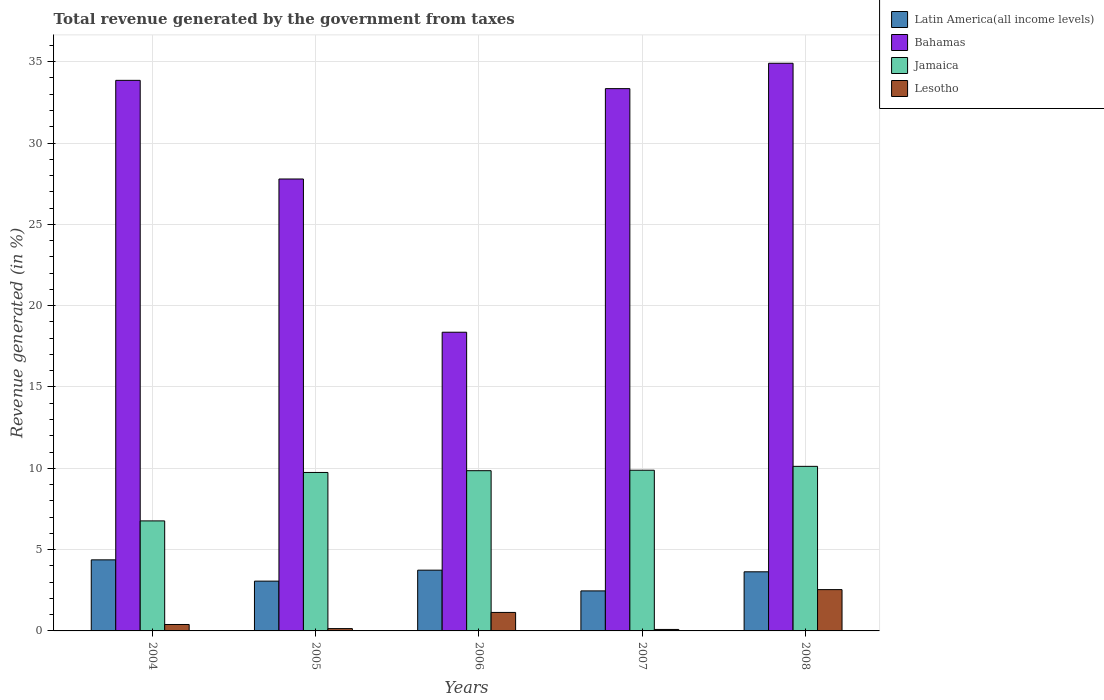How many groups of bars are there?
Give a very brief answer. 5. How many bars are there on the 2nd tick from the left?
Provide a short and direct response. 4. What is the label of the 1st group of bars from the left?
Provide a succinct answer. 2004. In how many cases, is the number of bars for a given year not equal to the number of legend labels?
Offer a terse response. 0. What is the total revenue generated in Latin America(all income levels) in 2006?
Ensure brevity in your answer.  3.74. Across all years, what is the maximum total revenue generated in Lesotho?
Your answer should be compact. 2.54. Across all years, what is the minimum total revenue generated in Bahamas?
Provide a short and direct response. 18.37. In which year was the total revenue generated in Bahamas maximum?
Provide a short and direct response. 2008. In which year was the total revenue generated in Bahamas minimum?
Your answer should be compact. 2006. What is the total total revenue generated in Jamaica in the graph?
Provide a short and direct response. 46.36. What is the difference between the total revenue generated in Bahamas in 2005 and that in 2008?
Keep it short and to the point. -7.12. What is the difference between the total revenue generated in Jamaica in 2007 and the total revenue generated in Bahamas in 2005?
Offer a very short reply. -17.91. What is the average total revenue generated in Lesotho per year?
Offer a terse response. 0.86. In the year 2007, what is the difference between the total revenue generated in Jamaica and total revenue generated in Bahamas?
Your answer should be compact. -23.46. What is the ratio of the total revenue generated in Lesotho in 2004 to that in 2005?
Your answer should be compact. 2.77. Is the total revenue generated in Lesotho in 2004 less than that in 2007?
Offer a very short reply. No. What is the difference between the highest and the second highest total revenue generated in Lesotho?
Provide a short and direct response. 1.4. What is the difference between the highest and the lowest total revenue generated in Lesotho?
Make the answer very short. 2.45. In how many years, is the total revenue generated in Jamaica greater than the average total revenue generated in Jamaica taken over all years?
Provide a succinct answer. 4. Is it the case that in every year, the sum of the total revenue generated in Lesotho and total revenue generated in Bahamas is greater than the sum of total revenue generated in Jamaica and total revenue generated in Latin America(all income levels)?
Offer a terse response. No. What does the 3rd bar from the left in 2006 represents?
Your response must be concise. Jamaica. What does the 2nd bar from the right in 2007 represents?
Provide a short and direct response. Jamaica. Is it the case that in every year, the sum of the total revenue generated in Bahamas and total revenue generated in Lesotho is greater than the total revenue generated in Jamaica?
Your answer should be compact. Yes. Are all the bars in the graph horizontal?
Make the answer very short. No. Does the graph contain grids?
Ensure brevity in your answer.  Yes. How many legend labels are there?
Make the answer very short. 4. What is the title of the graph?
Keep it short and to the point. Total revenue generated by the government from taxes. Does "Cameroon" appear as one of the legend labels in the graph?
Ensure brevity in your answer.  No. What is the label or title of the X-axis?
Offer a very short reply. Years. What is the label or title of the Y-axis?
Your answer should be very brief. Revenue generated (in %). What is the Revenue generated (in %) of Latin America(all income levels) in 2004?
Keep it short and to the point. 4.37. What is the Revenue generated (in %) in Bahamas in 2004?
Provide a succinct answer. 33.85. What is the Revenue generated (in %) in Jamaica in 2004?
Your response must be concise. 6.77. What is the Revenue generated (in %) in Lesotho in 2004?
Ensure brevity in your answer.  0.4. What is the Revenue generated (in %) in Latin America(all income levels) in 2005?
Keep it short and to the point. 3.06. What is the Revenue generated (in %) in Bahamas in 2005?
Your answer should be compact. 27.79. What is the Revenue generated (in %) in Jamaica in 2005?
Keep it short and to the point. 9.74. What is the Revenue generated (in %) of Lesotho in 2005?
Provide a short and direct response. 0.14. What is the Revenue generated (in %) in Latin America(all income levels) in 2006?
Keep it short and to the point. 3.74. What is the Revenue generated (in %) of Bahamas in 2006?
Your answer should be compact. 18.37. What is the Revenue generated (in %) of Jamaica in 2006?
Provide a succinct answer. 9.85. What is the Revenue generated (in %) in Lesotho in 2006?
Offer a terse response. 1.14. What is the Revenue generated (in %) in Latin America(all income levels) in 2007?
Your answer should be very brief. 2.46. What is the Revenue generated (in %) of Bahamas in 2007?
Offer a very short reply. 33.35. What is the Revenue generated (in %) of Jamaica in 2007?
Offer a very short reply. 9.88. What is the Revenue generated (in %) of Lesotho in 2007?
Provide a succinct answer. 0.09. What is the Revenue generated (in %) of Latin America(all income levels) in 2008?
Provide a short and direct response. 3.64. What is the Revenue generated (in %) of Bahamas in 2008?
Provide a short and direct response. 34.91. What is the Revenue generated (in %) of Jamaica in 2008?
Offer a terse response. 10.12. What is the Revenue generated (in %) in Lesotho in 2008?
Ensure brevity in your answer.  2.54. Across all years, what is the maximum Revenue generated (in %) of Latin America(all income levels)?
Provide a succinct answer. 4.37. Across all years, what is the maximum Revenue generated (in %) of Bahamas?
Ensure brevity in your answer.  34.91. Across all years, what is the maximum Revenue generated (in %) in Jamaica?
Your response must be concise. 10.12. Across all years, what is the maximum Revenue generated (in %) in Lesotho?
Provide a short and direct response. 2.54. Across all years, what is the minimum Revenue generated (in %) in Latin America(all income levels)?
Keep it short and to the point. 2.46. Across all years, what is the minimum Revenue generated (in %) of Bahamas?
Your response must be concise. 18.37. Across all years, what is the minimum Revenue generated (in %) in Jamaica?
Offer a very short reply. 6.77. Across all years, what is the minimum Revenue generated (in %) in Lesotho?
Provide a short and direct response. 0.09. What is the total Revenue generated (in %) of Latin America(all income levels) in the graph?
Provide a succinct answer. 17.26. What is the total Revenue generated (in %) of Bahamas in the graph?
Give a very brief answer. 148.26. What is the total Revenue generated (in %) in Jamaica in the graph?
Your response must be concise. 46.36. What is the total Revenue generated (in %) in Lesotho in the graph?
Provide a short and direct response. 4.31. What is the difference between the Revenue generated (in %) of Latin America(all income levels) in 2004 and that in 2005?
Offer a terse response. 1.31. What is the difference between the Revenue generated (in %) in Bahamas in 2004 and that in 2005?
Your answer should be very brief. 6.07. What is the difference between the Revenue generated (in %) of Jamaica in 2004 and that in 2005?
Keep it short and to the point. -2.98. What is the difference between the Revenue generated (in %) in Lesotho in 2004 and that in 2005?
Provide a succinct answer. 0.25. What is the difference between the Revenue generated (in %) of Latin America(all income levels) in 2004 and that in 2006?
Give a very brief answer. 0.63. What is the difference between the Revenue generated (in %) of Bahamas in 2004 and that in 2006?
Provide a short and direct response. 15.49. What is the difference between the Revenue generated (in %) in Jamaica in 2004 and that in 2006?
Provide a short and direct response. -3.09. What is the difference between the Revenue generated (in %) of Lesotho in 2004 and that in 2006?
Your response must be concise. -0.74. What is the difference between the Revenue generated (in %) in Latin America(all income levels) in 2004 and that in 2007?
Make the answer very short. 1.91. What is the difference between the Revenue generated (in %) of Bahamas in 2004 and that in 2007?
Offer a very short reply. 0.51. What is the difference between the Revenue generated (in %) of Jamaica in 2004 and that in 2007?
Ensure brevity in your answer.  -3.12. What is the difference between the Revenue generated (in %) in Lesotho in 2004 and that in 2007?
Offer a terse response. 0.3. What is the difference between the Revenue generated (in %) in Latin America(all income levels) in 2004 and that in 2008?
Offer a very short reply. 0.73. What is the difference between the Revenue generated (in %) of Bahamas in 2004 and that in 2008?
Provide a succinct answer. -1.05. What is the difference between the Revenue generated (in %) of Jamaica in 2004 and that in 2008?
Offer a terse response. -3.35. What is the difference between the Revenue generated (in %) in Lesotho in 2004 and that in 2008?
Your answer should be compact. -2.14. What is the difference between the Revenue generated (in %) of Latin America(all income levels) in 2005 and that in 2006?
Provide a short and direct response. -0.67. What is the difference between the Revenue generated (in %) in Bahamas in 2005 and that in 2006?
Provide a short and direct response. 9.42. What is the difference between the Revenue generated (in %) of Jamaica in 2005 and that in 2006?
Your response must be concise. -0.11. What is the difference between the Revenue generated (in %) of Lesotho in 2005 and that in 2006?
Provide a short and direct response. -0.99. What is the difference between the Revenue generated (in %) of Latin America(all income levels) in 2005 and that in 2007?
Give a very brief answer. 0.6. What is the difference between the Revenue generated (in %) of Bahamas in 2005 and that in 2007?
Provide a succinct answer. -5.56. What is the difference between the Revenue generated (in %) of Jamaica in 2005 and that in 2007?
Offer a terse response. -0.14. What is the difference between the Revenue generated (in %) of Lesotho in 2005 and that in 2007?
Keep it short and to the point. 0.05. What is the difference between the Revenue generated (in %) in Latin America(all income levels) in 2005 and that in 2008?
Ensure brevity in your answer.  -0.57. What is the difference between the Revenue generated (in %) in Bahamas in 2005 and that in 2008?
Give a very brief answer. -7.12. What is the difference between the Revenue generated (in %) of Jamaica in 2005 and that in 2008?
Keep it short and to the point. -0.38. What is the difference between the Revenue generated (in %) of Lesotho in 2005 and that in 2008?
Give a very brief answer. -2.4. What is the difference between the Revenue generated (in %) of Latin America(all income levels) in 2006 and that in 2007?
Provide a short and direct response. 1.28. What is the difference between the Revenue generated (in %) of Bahamas in 2006 and that in 2007?
Provide a succinct answer. -14.98. What is the difference between the Revenue generated (in %) of Jamaica in 2006 and that in 2007?
Provide a succinct answer. -0.03. What is the difference between the Revenue generated (in %) in Lesotho in 2006 and that in 2007?
Keep it short and to the point. 1.05. What is the difference between the Revenue generated (in %) of Latin America(all income levels) in 2006 and that in 2008?
Your answer should be very brief. 0.1. What is the difference between the Revenue generated (in %) of Bahamas in 2006 and that in 2008?
Make the answer very short. -16.54. What is the difference between the Revenue generated (in %) in Jamaica in 2006 and that in 2008?
Offer a very short reply. -0.27. What is the difference between the Revenue generated (in %) of Lesotho in 2006 and that in 2008?
Provide a short and direct response. -1.4. What is the difference between the Revenue generated (in %) in Latin America(all income levels) in 2007 and that in 2008?
Your answer should be very brief. -1.17. What is the difference between the Revenue generated (in %) in Bahamas in 2007 and that in 2008?
Ensure brevity in your answer.  -1.56. What is the difference between the Revenue generated (in %) in Jamaica in 2007 and that in 2008?
Make the answer very short. -0.24. What is the difference between the Revenue generated (in %) of Lesotho in 2007 and that in 2008?
Your response must be concise. -2.45. What is the difference between the Revenue generated (in %) of Latin America(all income levels) in 2004 and the Revenue generated (in %) of Bahamas in 2005?
Offer a very short reply. -23.42. What is the difference between the Revenue generated (in %) in Latin America(all income levels) in 2004 and the Revenue generated (in %) in Jamaica in 2005?
Ensure brevity in your answer.  -5.37. What is the difference between the Revenue generated (in %) of Latin America(all income levels) in 2004 and the Revenue generated (in %) of Lesotho in 2005?
Provide a succinct answer. 4.23. What is the difference between the Revenue generated (in %) of Bahamas in 2004 and the Revenue generated (in %) of Jamaica in 2005?
Give a very brief answer. 24.11. What is the difference between the Revenue generated (in %) of Bahamas in 2004 and the Revenue generated (in %) of Lesotho in 2005?
Your answer should be compact. 33.71. What is the difference between the Revenue generated (in %) in Jamaica in 2004 and the Revenue generated (in %) in Lesotho in 2005?
Offer a terse response. 6.62. What is the difference between the Revenue generated (in %) in Latin America(all income levels) in 2004 and the Revenue generated (in %) in Bahamas in 2006?
Offer a terse response. -14. What is the difference between the Revenue generated (in %) of Latin America(all income levels) in 2004 and the Revenue generated (in %) of Jamaica in 2006?
Your answer should be compact. -5.48. What is the difference between the Revenue generated (in %) of Latin America(all income levels) in 2004 and the Revenue generated (in %) of Lesotho in 2006?
Provide a short and direct response. 3.23. What is the difference between the Revenue generated (in %) of Bahamas in 2004 and the Revenue generated (in %) of Jamaica in 2006?
Offer a very short reply. 24. What is the difference between the Revenue generated (in %) of Bahamas in 2004 and the Revenue generated (in %) of Lesotho in 2006?
Offer a very short reply. 32.72. What is the difference between the Revenue generated (in %) in Jamaica in 2004 and the Revenue generated (in %) in Lesotho in 2006?
Keep it short and to the point. 5.63. What is the difference between the Revenue generated (in %) of Latin America(all income levels) in 2004 and the Revenue generated (in %) of Bahamas in 2007?
Provide a succinct answer. -28.98. What is the difference between the Revenue generated (in %) of Latin America(all income levels) in 2004 and the Revenue generated (in %) of Jamaica in 2007?
Ensure brevity in your answer.  -5.51. What is the difference between the Revenue generated (in %) in Latin America(all income levels) in 2004 and the Revenue generated (in %) in Lesotho in 2007?
Your answer should be compact. 4.28. What is the difference between the Revenue generated (in %) of Bahamas in 2004 and the Revenue generated (in %) of Jamaica in 2007?
Your answer should be very brief. 23.97. What is the difference between the Revenue generated (in %) in Bahamas in 2004 and the Revenue generated (in %) in Lesotho in 2007?
Keep it short and to the point. 33.76. What is the difference between the Revenue generated (in %) in Jamaica in 2004 and the Revenue generated (in %) in Lesotho in 2007?
Make the answer very short. 6.67. What is the difference between the Revenue generated (in %) in Latin America(all income levels) in 2004 and the Revenue generated (in %) in Bahamas in 2008?
Your response must be concise. -30.54. What is the difference between the Revenue generated (in %) of Latin America(all income levels) in 2004 and the Revenue generated (in %) of Jamaica in 2008?
Provide a short and direct response. -5.75. What is the difference between the Revenue generated (in %) of Latin America(all income levels) in 2004 and the Revenue generated (in %) of Lesotho in 2008?
Your answer should be very brief. 1.83. What is the difference between the Revenue generated (in %) of Bahamas in 2004 and the Revenue generated (in %) of Jamaica in 2008?
Give a very brief answer. 23.74. What is the difference between the Revenue generated (in %) in Bahamas in 2004 and the Revenue generated (in %) in Lesotho in 2008?
Provide a succinct answer. 31.31. What is the difference between the Revenue generated (in %) of Jamaica in 2004 and the Revenue generated (in %) of Lesotho in 2008?
Make the answer very short. 4.23. What is the difference between the Revenue generated (in %) of Latin America(all income levels) in 2005 and the Revenue generated (in %) of Bahamas in 2006?
Provide a short and direct response. -15.31. What is the difference between the Revenue generated (in %) of Latin America(all income levels) in 2005 and the Revenue generated (in %) of Jamaica in 2006?
Your response must be concise. -6.79. What is the difference between the Revenue generated (in %) in Latin America(all income levels) in 2005 and the Revenue generated (in %) in Lesotho in 2006?
Give a very brief answer. 1.92. What is the difference between the Revenue generated (in %) in Bahamas in 2005 and the Revenue generated (in %) in Jamaica in 2006?
Provide a succinct answer. 17.94. What is the difference between the Revenue generated (in %) in Bahamas in 2005 and the Revenue generated (in %) in Lesotho in 2006?
Offer a very short reply. 26.65. What is the difference between the Revenue generated (in %) in Jamaica in 2005 and the Revenue generated (in %) in Lesotho in 2006?
Provide a succinct answer. 8.61. What is the difference between the Revenue generated (in %) in Latin America(all income levels) in 2005 and the Revenue generated (in %) in Bahamas in 2007?
Keep it short and to the point. -30.28. What is the difference between the Revenue generated (in %) of Latin America(all income levels) in 2005 and the Revenue generated (in %) of Jamaica in 2007?
Your answer should be compact. -6.82. What is the difference between the Revenue generated (in %) in Latin America(all income levels) in 2005 and the Revenue generated (in %) in Lesotho in 2007?
Offer a very short reply. 2.97. What is the difference between the Revenue generated (in %) in Bahamas in 2005 and the Revenue generated (in %) in Jamaica in 2007?
Offer a very short reply. 17.91. What is the difference between the Revenue generated (in %) of Bahamas in 2005 and the Revenue generated (in %) of Lesotho in 2007?
Make the answer very short. 27.7. What is the difference between the Revenue generated (in %) in Jamaica in 2005 and the Revenue generated (in %) in Lesotho in 2007?
Keep it short and to the point. 9.65. What is the difference between the Revenue generated (in %) in Latin America(all income levels) in 2005 and the Revenue generated (in %) in Bahamas in 2008?
Ensure brevity in your answer.  -31.84. What is the difference between the Revenue generated (in %) in Latin America(all income levels) in 2005 and the Revenue generated (in %) in Jamaica in 2008?
Offer a very short reply. -7.06. What is the difference between the Revenue generated (in %) in Latin America(all income levels) in 2005 and the Revenue generated (in %) in Lesotho in 2008?
Your answer should be compact. 0.52. What is the difference between the Revenue generated (in %) of Bahamas in 2005 and the Revenue generated (in %) of Jamaica in 2008?
Offer a terse response. 17.67. What is the difference between the Revenue generated (in %) in Bahamas in 2005 and the Revenue generated (in %) in Lesotho in 2008?
Give a very brief answer. 25.25. What is the difference between the Revenue generated (in %) in Jamaica in 2005 and the Revenue generated (in %) in Lesotho in 2008?
Give a very brief answer. 7.2. What is the difference between the Revenue generated (in %) of Latin America(all income levels) in 2006 and the Revenue generated (in %) of Bahamas in 2007?
Ensure brevity in your answer.  -29.61. What is the difference between the Revenue generated (in %) in Latin America(all income levels) in 2006 and the Revenue generated (in %) in Jamaica in 2007?
Offer a terse response. -6.15. What is the difference between the Revenue generated (in %) in Latin America(all income levels) in 2006 and the Revenue generated (in %) in Lesotho in 2007?
Make the answer very short. 3.65. What is the difference between the Revenue generated (in %) of Bahamas in 2006 and the Revenue generated (in %) of Jamaica in 2007?
Your answer should be compact. 8.49. What is the difference between the Revenue generated (in %) in Bahamas in 2006 and the Revenue generated (in %) in Lesotho in 2007?
Offer a terse response. 18.28. What is the difference between the Revenue generated (in %) in Jamaica in 2006 and the Revenue generated (in %) in Lesotho in 2007?
Keep it short and to the point. 9.76. What is the difference between the Revenue generated (in %) in Latin America(all income levels) in 2006 and the Revenue generated (in %) in Bahamas in 2008?
Provide a short and direct response. -31.17. What is the difference between the Revenue generated (in %) of Latin America(all income levels) in 2006 and the Revenue generated (in %) of Jamaica in 2008?
Make the answer very short. -6.38. What is the difference between the Revenue generated (in %) in Latin America(all income levels) in 2006 and the Revenue generated (in %) in Lesotho in 2008?
Keep it short and to the point. 1.2. What is the difference between the Revenue generated (in %) in Bahamas in 2006 and the Revenue generated (in %) in Jamaica in 2008?
Provide a short and direct response. 8.25. What is the difference between the Revenue generated (in %) of Bahamas in 2006 and the Revenue generated (in %) of Lesotho in 2008?
Offer a very short reply. 15.83. What is the difference between the Revenue generated (in %) of Jamaica in 2006 and the Revenue generated (in %) of Lesotho in 2008?
Your answer should be very brief. 7.31. What is the difference between the Revenue generated (in %) in Latin America(all income levels) in 2007 and the Revenue generated (in %) in Bahamas in 2008?
Provide a short and direct response. -32.44. What is the difference between the Revenue generated (in %) of Latin America(all income levels) in 2007 and the Revenue generated (in %) of Jamaica in 2008?
Offer a very short reply. -7.66. What is the difference between the Revenue generated (in %) in Latin America(all income levels) in 2007 and the Revenue generated (in %) in Lesotho in 2008?
Give a very brief answer. -0.08. What is the difference between the Revenue generated (in %) of Bahamas in 2007 and the Revenue generated (in %) of Jamaica in 2008?
Offer a terse response. 23.23. What is the difference between the Revenue generated (in %) in Bahamas in 2007 and the Revenue generated (in %) in Lesotho in 2008?
Provide a short and direct response. 30.81. What is the difference between the Revenue generated (in %) in Jamaica in 2007 and the Revenue generated (in %) in Lesotho in 2008?
Make the answer very short. 7.34. What is the average Revenue generated (in %) of Latin America(all income levels) per year?
Keep it short and to the point. 3.45. What is the average Revenue generated (in %) of Bahamas per year?
Provide a succinct answer. 29.65. What is the average Revenue generated (in %) of Jamaica per year?
Your response must be concise. 9.27. What is the average Revenue generated (in %) in Lesotho per year?
Offer a very short reply. 0.86. In the year 2004, what is the difference between the Revenue generated (in %) of Latin America(all income levels) and Revenue generated (in %) of Bahamas?
Give a very brief answer. -29.48. In the year 2004, what is the difference between the Revenue generated (in %) in Latin America(all income levels) and Revenue generated (in %) in Jamaica?
Ensure brevity in your answer.  -2.4. In the year 2004, what is the difference between the Revenue generated (in %) in Latin America(all income levels) and Revenue generated (in %) in Lesotho?
Offer a terse response. 3.97. In the year 2004, what is the difference between the Revenue generated (in %) in Bahamas and Revenue generated (in %) in Jamaica?
Your answer should be compact. 27.09. In the year 2004, what is the difference between the Revenue generated (in %) in Bahamas and Revenue generated (in %) in Lesotho?
Provide a succinct answer. 33.46. In the year 2004, what is the difference between the Revenue generated (in %) in Jamaica and Revenue generated (in %) in Lesotho?
Your answer should be compact. 6.37. In the year 2005, what is the difference between the Revenue generated (in %) of Latin America(all income levels) and Revenue generated (in %) of Bahamas?
Ensure brevity in your answer.  -24.73. In the year 2005, what is the difference between the Revenue generated (in %) of Latin America(all income levels) and Revenue generated (in %) of Jamaica?
Your answer should be very brief. -6.68. In the year 2005, what is the difference between the Revenue generated (in %) in Latin America(all income levels) and Revenue generated (in %) in Lesotho?
Offer a very short reply. 2.92. In the year 2005, what is the difference between the Revenue generated (in %) of Bahamas and Revenue generated (in %) of Jamaica?
Offer a terse response. 18.05. In the year 2005, what is the difference between the Revenue generated (in %) of Bahamas and Revenue generated (in %) of Lesotho?
Your answer should be compact. 27.65. In the year 2005, what is the difference between the Revenue generated (in %) of Jamaica and Revenue generated (in %) of Lesotho?
Provide a short and direct response. 9.6. In the year 2006, what is the difference between the Revenue generated (in %) in Latin America(all income levels) and Revenue generated (in %) in Bahamas?
Offer a terse response. -14.63. In the year 2006, what is the difference between the Revenue generated (in %) of Latin America(all income levels) and Revenue generated (in %) of Jamaica?
Provide a succinct answer. -6.12. In the year 2006, what is the difference between the Revenue generated (in %) in Latin America(all income levels) and Revenue generated (in %) in Lesotho?
Make the answer very short. 2.6. In the year 2006, what is the difference between the Revenue generated (in %) in Bahamas and Revenue generated (in %) in Jamaica?
Offer a terse response. 8.51. In the year 2006, what is the difference between the Revenue generated (in %) of Bahamas and Revenue generated (in %) of Lesotho?
Keep it short and to the point. 17.23. In the year 2006, what is the difference between the Revenue generated (in %) of Jamaica and Revenue generated (in %) of Lesotho?
Ensure brevity in your answer.  8.72. In the year 2007, what is the difference between the Revenue generated (in %) in Latin America(all income levels) and Revenue generated (in %) in Bahamas?
Your answer should be very brief. -30.88. In the year 2007, what is the difference between the Revenue generated (in %) in Latin America(all income levels) and Revenue generated (in %) in Jamaica?
Give a very brief answer. -7.42. In the year 2007, what is the difference between the Revenue generated (in %) in Latin America(all income levels) and Revenue generated (in %) in Lesotho?
Provide a short and direct response. 2.37. In the year 2007, what is the difference between the Revenue generated (in %) of Bahamas and Revenue generated (in %) of Jamaica?
Make the answer very short. 23.46. In the year 2007, what is the difference between the Revenue generated (in %) of Bahamas and Revenue generated (in %) of Lesotho?
Your answer should be very brief. 33.25. In the year 2007, what is the difference between the Revenue generated (in %) of Jamaica and Revenue generated (in %) of Lesotho?
Give a very brief answer. 9.79. In the year 2008, what is the difference between the Revenue generated (in %) in Latin America(all income levels) and Revenue generated (in %) in Bahamas?
Your answer should be compact. -31.27. In the year 2008, what is the difference between the Revenue generated (in %) of Latin America(all income levels) and Revenue generated (in %) of Jamaica?
Provide a succinct answer. -6.48. In the year 2008, what is the difference between the Revenue generated (in %) in Latin America(all income levels) and Revenue generated (in %) in Lesotho?
Your response must be concise. 1.1. In the year 2008, what is the difference between the Revenue generated (in %) of Bahamas and Revenue generated (in %) of Jamaica?
Your response must be concise. 24.79. In the year 2008, what is the difference between the Revenue generated (in %) of Bahamas and Revenue generated (in %) of Lesotho?
Give a very brief answer. 32.37. In the year 2008, what is the difference between the Revenue generated (in %) of Jamaica and Revenue generated (in %) of Lesotho?
Ensure brevity in your answer.  7.58. What is the ratio of the Revenue generated (in %) in Latin America(all income levels) in 2004 to that in 2005?
Keep it short and to the point. 1.43. What is the ratio of the Revenue generated (in %) of Bahamas in 2004 to that in 2005?
Provide a succinct answer. 1.22. What is the ratio of the Revenue generated (in %) of Jamaica in 2004 to that in 2005?
Give a very brief answer. 0.69. What is the ratio of the Revenue generated (in %) in Lesotho in 2004 to that in 2005?
Your response must be concise. 2.77. What is the ratio of the Revenue generated (in %) of Latin America(all income levels) in 2004 to that in 2006?
Give a very brief answer. 1.17. What is the ratio of the Revenue generated (in %) of Bahamas in 2004 to that in 2006?
Provide a succinct answer. 1.84. What is the ratio of the Revenue generated (in %) of Jamaica in 2004 to that in 2006?
Make the answer very short. 0.69. What is the ratio of the Revenue generated (in %) of Lesotho in 2004 to that in 2006?
Ensure brevity in your answer.  0.35. What is the ratio of the Revenue generated (in %) in Latin America(all income levels) in 2004 to that in 2007?
Make the answer very short. 1.78. What is the ratio of the Revenue generated (in %) in Bahamas in 2004 to that in 2007?
Keep it short and to the point. 1.02. What is the ratio of the Revenue generated (in %) in Jamaica in 2004 to that in 2007?
Provide a short and direct response. 0.68. What is the ratio of the Revenue generated (in %) of Lesotho in 2004 to that in 2007?
Ensure brevity in your answer.  4.35. What is the ratio of the Revenue generated (in %) of Latin America(all income levels) in 2004 to that in 2008?
Provide a succinct answer. 1.2. What is the ratio of the Revenue generated (in %) in Bahamas in 2004 to that in 2008?
Give a very brief answer. 0.97. What is the ratio of the Revenue generated (in %) in Jamaica in 2004 to that in 2008?
Make the answer very short. 0.67. What is the ratio of the Revenue generated (in %) of Lesotho in 2004 to that in 2008?
Offer a very short reply. 0.16. What is the ratio of the Revenue generated (in %) of Latin America(all income levels) in 2005 to that in 2006?
Provide a short and direct response. 0.82. What is the ratio of the Revenue generated (in %) in Bahamas in 2005 to that in 2006?
Your answer should be compact. 1.51. What is the ratio of the Revenue generated (in %) of Lesotho in 2005 to that in 2006?
Your answer should be compact. 0.13. What is the ratio of the Revenue generated (in %) in Latin America(all income levels) in 2005 to that in 2007?
Provide a succinct answer. 1.24. What is the ratio of the Revenue generated (in %) in Bahamas in 2005 to that in 2007?
Provide a succinct answer. 0.83. What is the ratio of the Revenue generated (in %) in Jamaica in 2005 to that in 2007?
Offer a very short reply. 0.99. What is the ratio of the Revenue generated (in %) of Lesotho in 2005 to that in 2007?
Make the answer very short. 1.57. What is the ratio of the Revenue generated (in %) of Latin America(all income levels) in 2005 to that in 2008?
Provide a short and direct response. 0.84. What is the ratio of the Revenue generated (in %) of Bahamas in 2005 to that in 2008?
Make the answer very short. 0.8. What is the ratio of the Revenue generated (in %) in Jamaica in 2005 to that in 2008?
Your answer should be compact. 0.96. What is the ratio of the Revenue generated (in %) in Lesotho in 2005 to that in 2008?
Make the answer very short. 0.06. What is the ratio of the Revenue generated (in %) of Latin America(all income levels) in 2006 to that in 2007?
Your response must be concise. 1.52. What is the ratio of the Revenue generated (in %) of Bahamas in 2006 to that in 2007?
Give a very brief answer. 0.55. What is the ratio of the Revenue generated (in %) in Jamaica in 2006 to that in 2007?
Provide a succinct answer. 1. What is the ratio of the Revenue generated (in %) in Lesotho in 2006 to that in 2007?
Your answer should be very brief. 12.52. What is the ratio of the Revenue generated (in %) in Latin America(all income levels) in 2006 to that in 2008?
Ensure brevity in your answer.  1.03. What is the ratio of the Revenue generated (in %) in Bahamas in 2006 to that in 2008?
Give a very brief answer. 0.53. What is the ratio of the Revenue generated (in %) in Jamaica in 2006 to that in 2008?
Give a very brief answer. 0.97. What is the ratio of the Revenue generated (in %) of Lesotho in 2006 to that in 2008?
Give a very brief answer. 0.45. What is the ratio of the Revenue generated (in %) in Latin America(all income levels) in 2007 to that in 2008?
Offer a terse response. 0.68. What is the ratio of the Revenue generated (in %) of Bahamas in 2007 to that in 2008?
Make the answer very short. 0.96. What is the ratio of the Revenue generated (in %) in Jamaica in 2007 to that in 2008?
Offer a very short reply. 0.98. What is the ratio of the Revenue generated (in %) of Lesotho in 2007 to that in 2008?
Your answer should be compact. 0.04. What is the difference between the highest and the second highest Revenue generated (in %) of Latin America(all income levels)?
Your answer should be very brief. 0.63. What is the difference between the highest and the second highest Revenue generated (in %) of Bahamas?
Keep it short and to the point. 1.05. What is the difference between the highest and the second highest Revenue generated (in %) of Jamaica?
Keep it short and to the point. 0.24. What is the difference between the highest and the second highest Revenue generated (in %) in Lesotho?
Your response must be concise. 1.4. What is the difference between the highest and the lowest Revenue generated (in %) of Latin America(all income levels)?
Offer a terse response. 1.91. What is the difference between the highest and the lowest Revenue generated (in %) of Bahamas?
Your answer should be very brief. 16.54. What is the difference between the highest and the lowest Revenue generated (in %) in Jamaica?
Offer a very short reply. 3.35. What is the difference between the highest and the lowest Revenue generated (in %) in Lesotho?
Make the answer very short. 2.45. 